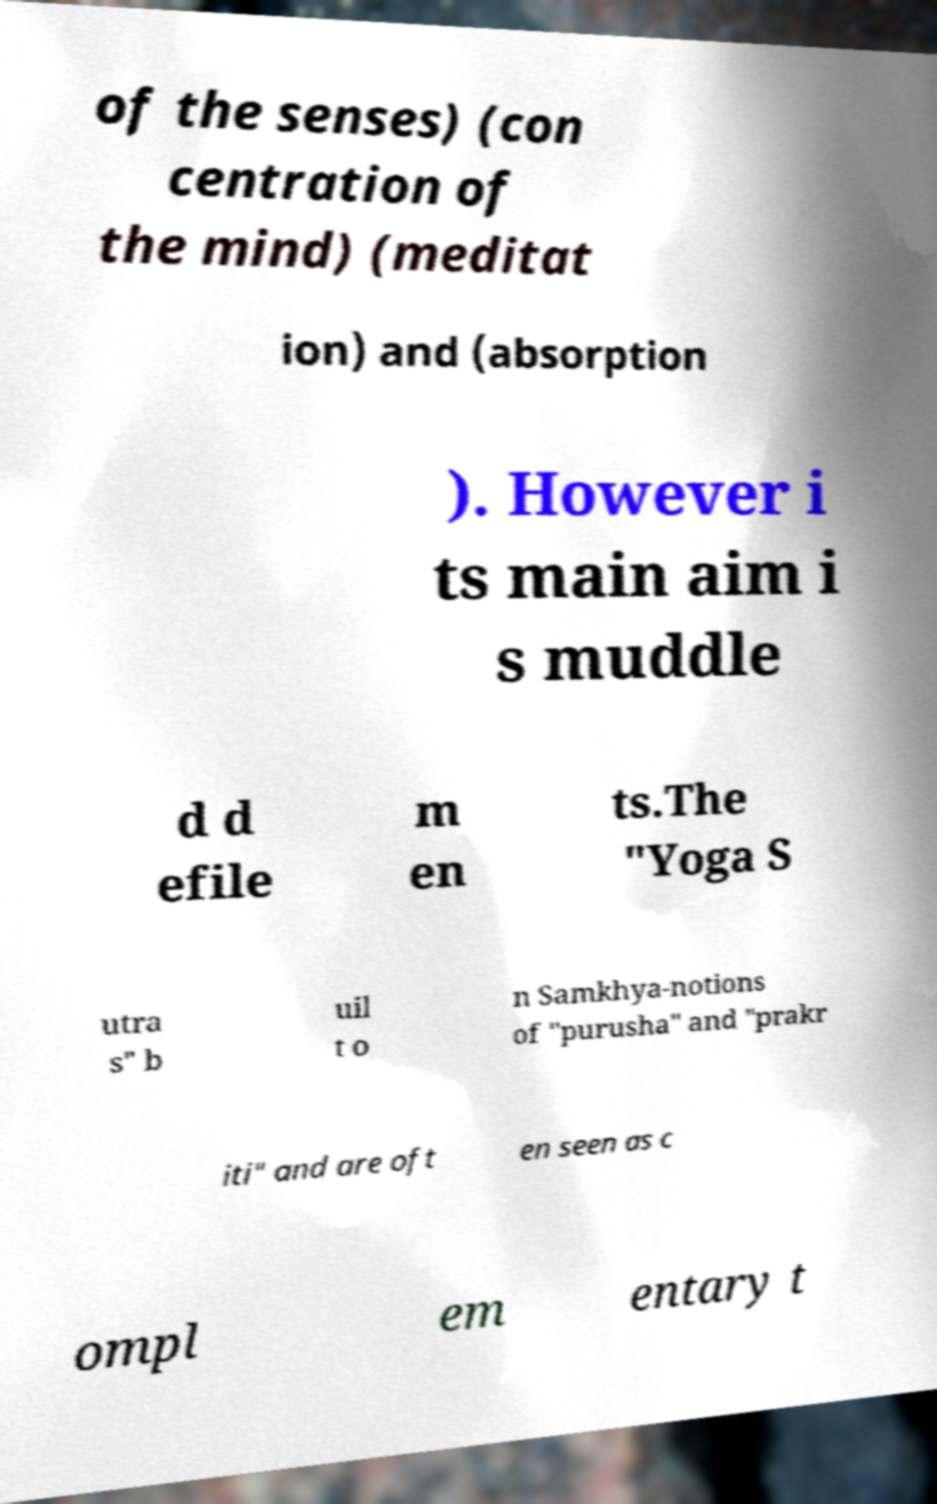There's text embedded in this image that I need extracted. Can you transcribe it verbatim? of the senses) (con centration of the mind) (meditat ion) and (absorption ). However i ts main aim i s muddle d d efile m en ts.The "Yoga S utra s" b uil t o n Samkhya-notions of "purusha" and "prakr iti" and are oft en seen as c ompl em entary t 